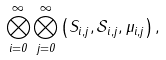Convert formula to latex. <formula><loc_0><loc_0><loc_500><loc_500>\bigotimes _ { i = 0 } ^ { \infty } \bigotimes _ { j = 0 } ^ { \infty } \left ( S _ { i , j } , \mathcal { S } _ { i , j } , \mu _ { i , j } \right ) ,</formula> 